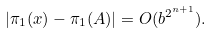Convert formula to latex. <formula><loc_0><loc_0><loc_500><loc_500>| \pi _ { 1 } ( x ) - \pi _ { 1 } ( A ) | = O ( b ^ { 2 ^ { n + 1 } } ) .</formula> 